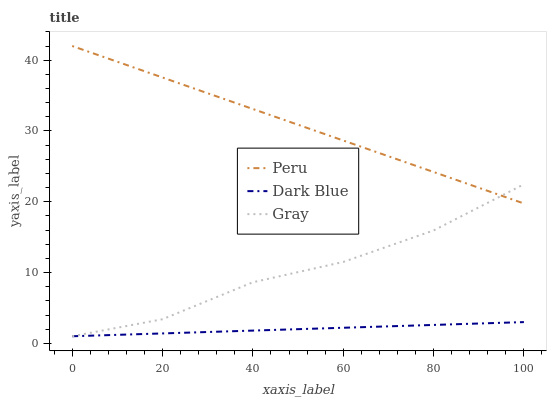Does Dark Blue have the minimum area under the curve?
Answer yes or no. Yes. Does Peru have the maximum area under the curve?
Answer yes or no. Yes. Does Gray have the minimum area under the curve?
Answer yes or no. No. Does Gray have the maximum area under the curve?
Answer yes or no. No. Is Peru the smoothest?
Answer yes or no. Yes. Is Gray the roughest?
Answer yes or no. Yes. Is Gray the smoothest?
Answer yes or no. No. Is Peru the roughest?
Answer yes or no. No. Does Dark Blue have the lowest value?
Answer yes or no. Yes. Does Peru have the lowest value?
Answer yes or no. No. Does Peru have the highest value?
Answer yes or no. Yes. Does Gray have the highest value?
Answer yes or no. No. Is Dark Blue less than Peru?
Answer yes or no. Yes. Is Peru greater than Dark Blue?
Answer yes or no. Yes. Does Dark Blue intersect Gray?
Answer yes or no. Yes. Is Dark Blue less than Gray?
Answer yes or no. No. Is Dark Blue greater than Gray?
Answer yes or no. No. Does Dark Blue intersect Peru?
Answer yes or no. No. 